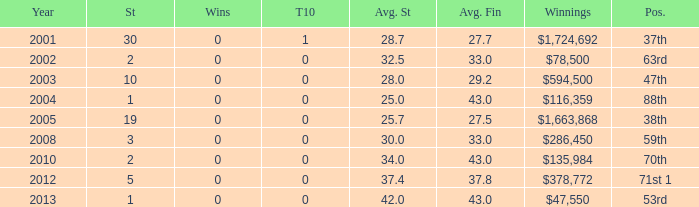What is the average top 10 score for 2 starts, winnings of $135,984 and an average finish more than 43? None. 